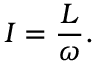Convert formula to latex. <formula><loc_0><loc_0><loc_500><loc_500>I = { \frac { L } { \omega } } .</formula> 